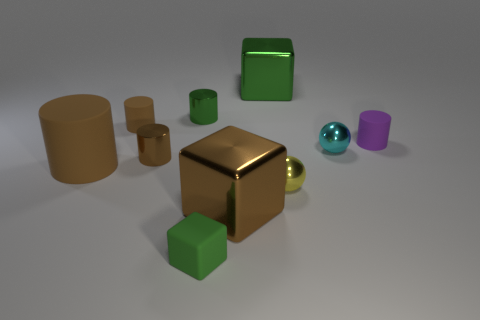What materials do the objects in the image seem to be made from? The objects in the image present a variety of textures that suggest they could be made from different materials. The large yellow cube has a reflective surface that could be metal or plastic with a metallic coating, while the green and purple objects have a matte finish indicative of a non-reflective material, such as painted wood or plastic. The sphere's translucence hints at glass or a transparent plastic composition. 